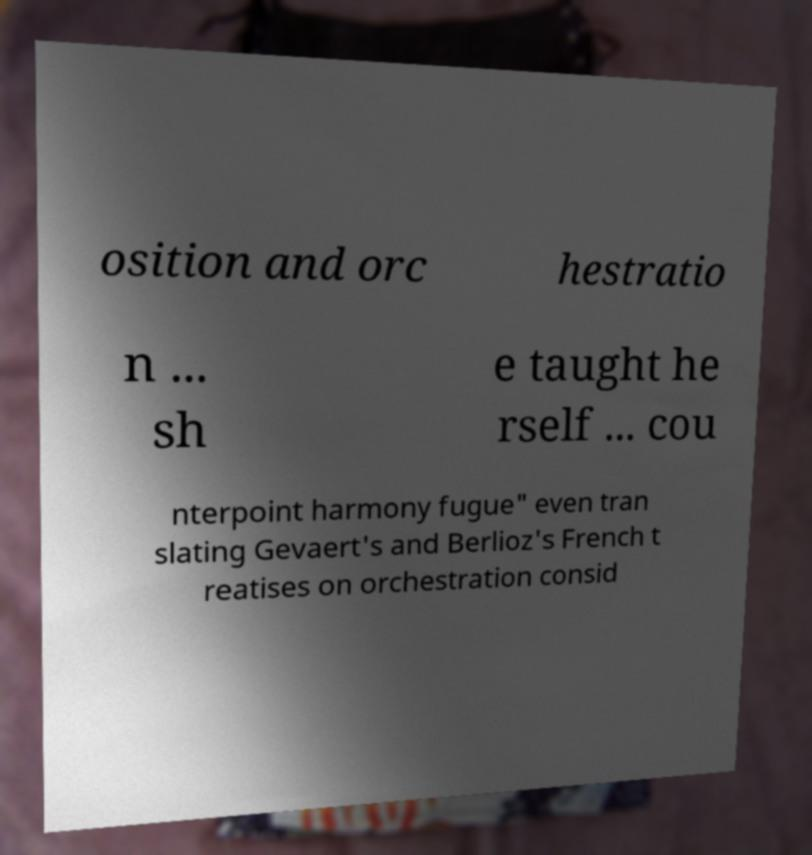There's text embedded in this image that I need extracted. Can you transcribe it verbatim? osition and orc hestratio n ... sh e taught he rself ... cou nterpoint harmony fugue" even tran slating Gevaert's and Berlioz's French t reatises on orchestration consid 